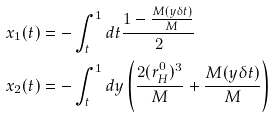<formula> <loc_0><loc_0><loc_500><loc_500>x _ { 1 } ( t ) & = - \int _ { t } ^ { 1 } d t \frac { 1 - \frac { M ( y \delta t ) } { M } } { 2 } \\ x _ { 2 } ( t ) & = - \int _ { t } ^ { 1 } d y \left ( \frac { 2 ( r ^ { 0 } _ { H } ) ^ { 3 } } { M } + \frac { M ( y \delta t ) } { M } \right ) \\</formula> 